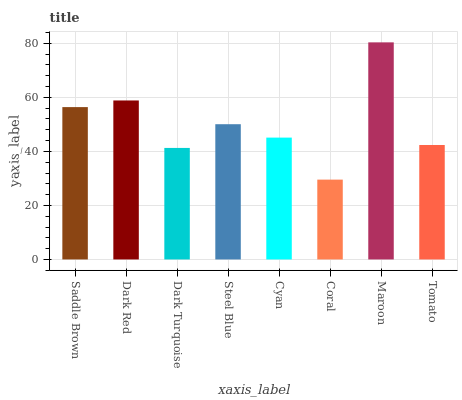Is Coral the minimum?
Answer yes or no. Yes. Is Maroon the maximum?
Answer yes or no. Yes. Is Dark Red the minimum?
Answer yes or no. No. Is Dark Red the maximum?
Answer yes or no. No. Is Dark Red greater than Saddle Brown?
Answer yes or no. Yes. Is Saddle Brown less than Dark Red?
Answer yes or no. Yes. Is Saddle Brown greater than Dark Red?
Answer yes or no. No. Is Dark Red less than Saddle Brown?
Answer yes or no. No. Is Steel Blue the high median?
Answer yes or no. Yes. Is Cyan the low median?
Answer yes or no. Yes. Is Dark Red the high median?
Answer yes or no. No. Is Dark Red the low median?
Answer yes or no. No. 